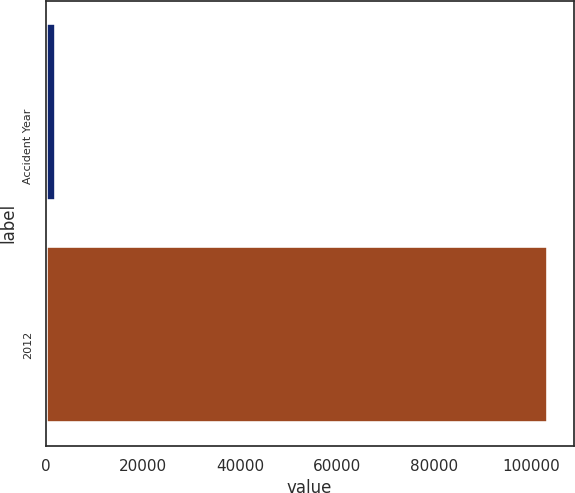<chart> <loc_0><loc_0><loc_500><loc_500><bar_chart><fcel>Accident Year<fcel>2012<nl><fcel>2016<fcel>103489<nl></chart> 